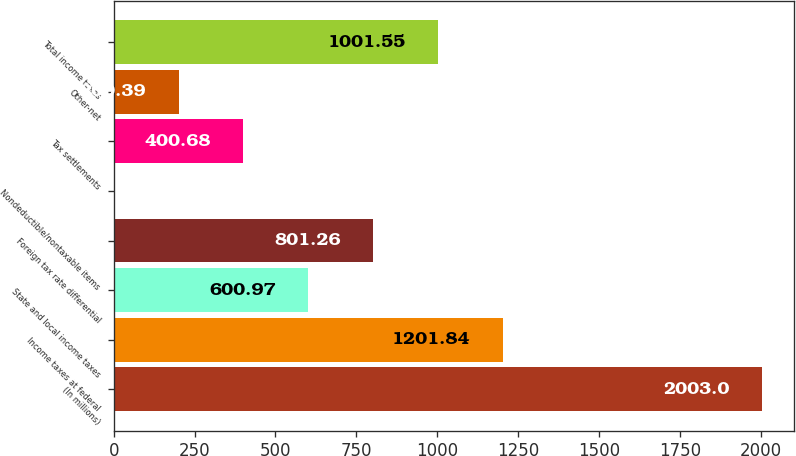Convert chart. <chart><loc_0><loc_0><loc_500><loc_500><bar_chart><fcel>(In millions)<fcel>Income taxes at federal<fcel>State and local income taxes<fcel>Foreign tax rate differential<fcel>Nondeductible/nontaxable items<fcel>Tax settlements<fcel>Other-net<fcel>Total income taxes<nl><fcel>2003<fcel>1201.84<fcel>600.97<fcel>801.26<fcel>0.1<fcel>400.68<fcel>200.39<fcel>1001.55<nl></chart> 